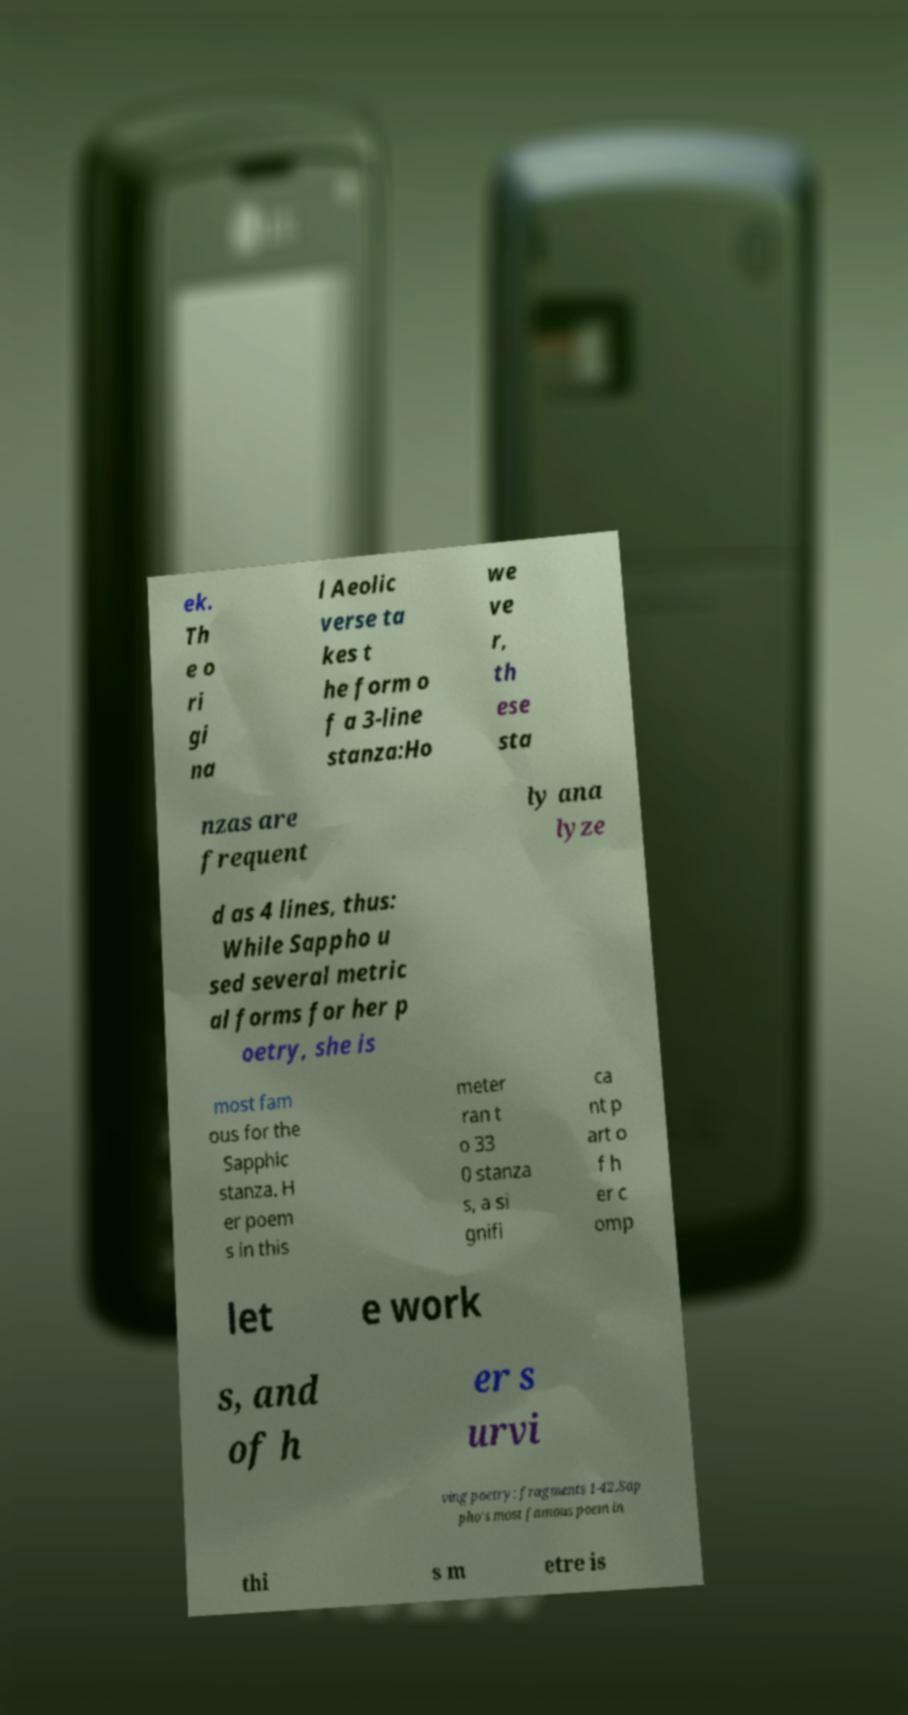I need the written content from this picture converted into text. Can you do that? ek. Th e o ri gi na l Aeolic verse ta kes t he form o f a 3-line stanza:Ho we ve r, th ese sta nzas are frequent ly ana lyze d as 4 lines, thus: While Sappho u sed several metric al forms for her p oetry, she is most fam ous for the Sapphic stanza. H er poem s in this meter ran t o 33 0 stanza s, a si gnifi ca nt p art o f h er c omp let e work s, and of h er s urvi ving poetry: fragments 1-42.Sap pho's most famous poem in thi s m etre is 